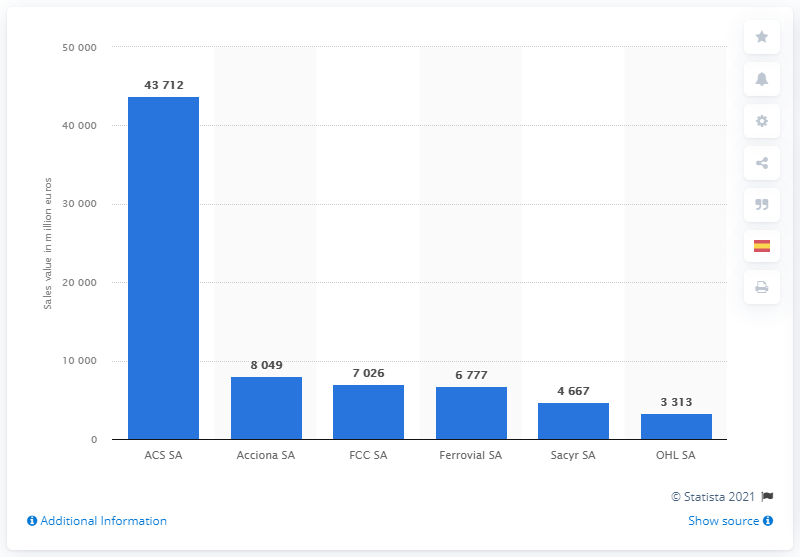Outline some significant characteristics in this image. The sum of the first and last blue bar is 47025. The tallest blue bar represents the ACS SA. FCC SA, a construction company in Spain, ranked third. 